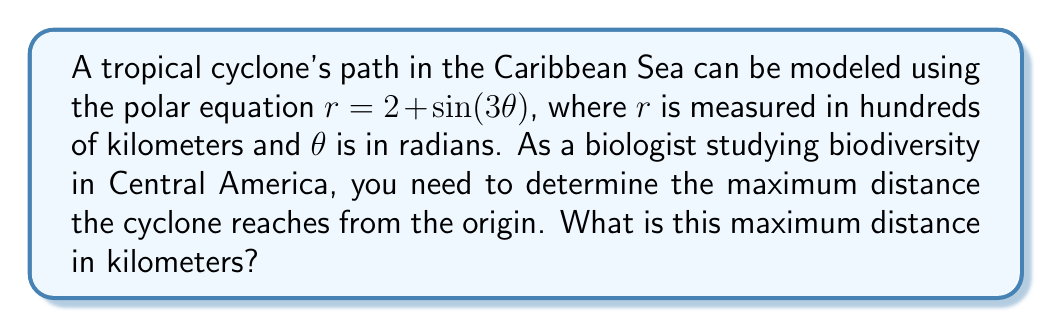Help me with this question. To find the maximum distance of the cyclone from the origin, we need to determine the maximum value of $r$ in the given polar equation.

1) The equation is given as $r = 2 + \sin(3\theta)$

2) The maximum value of sine function is 1, which occurs when its argument is $\frac{\pi}{2}$ or odd multiples of it.

3) So, we need to solve:
   $3\theta = \frac{\pi}{2}$ or $3\theta = \frac{5\pi}{2}$ or $3\theta = \frac{9\pi}{2}$, etc.

4) The first solution is $\theta = \frac{\pi}{6}$, which is sufficient for our purpose as the function repeats every $\frac{2\pi}{3}$.

5) At this maximum point:
   $r_{max} = 2 + \sin(3 \cdot \frac{\pi}{6}) = 2 + \sin(\frac{\pi}{2}) = 2 + 1 = 3$

6) Remember that $r$ is measured in hundreds of kilometers. So the actual maximum distance is:
   $3 \times 100 = 300$ kilometers

Therefore, the maximum distance the cyclone reaches from the origin is 300 kilometers.
Answer: 300 kilometers 